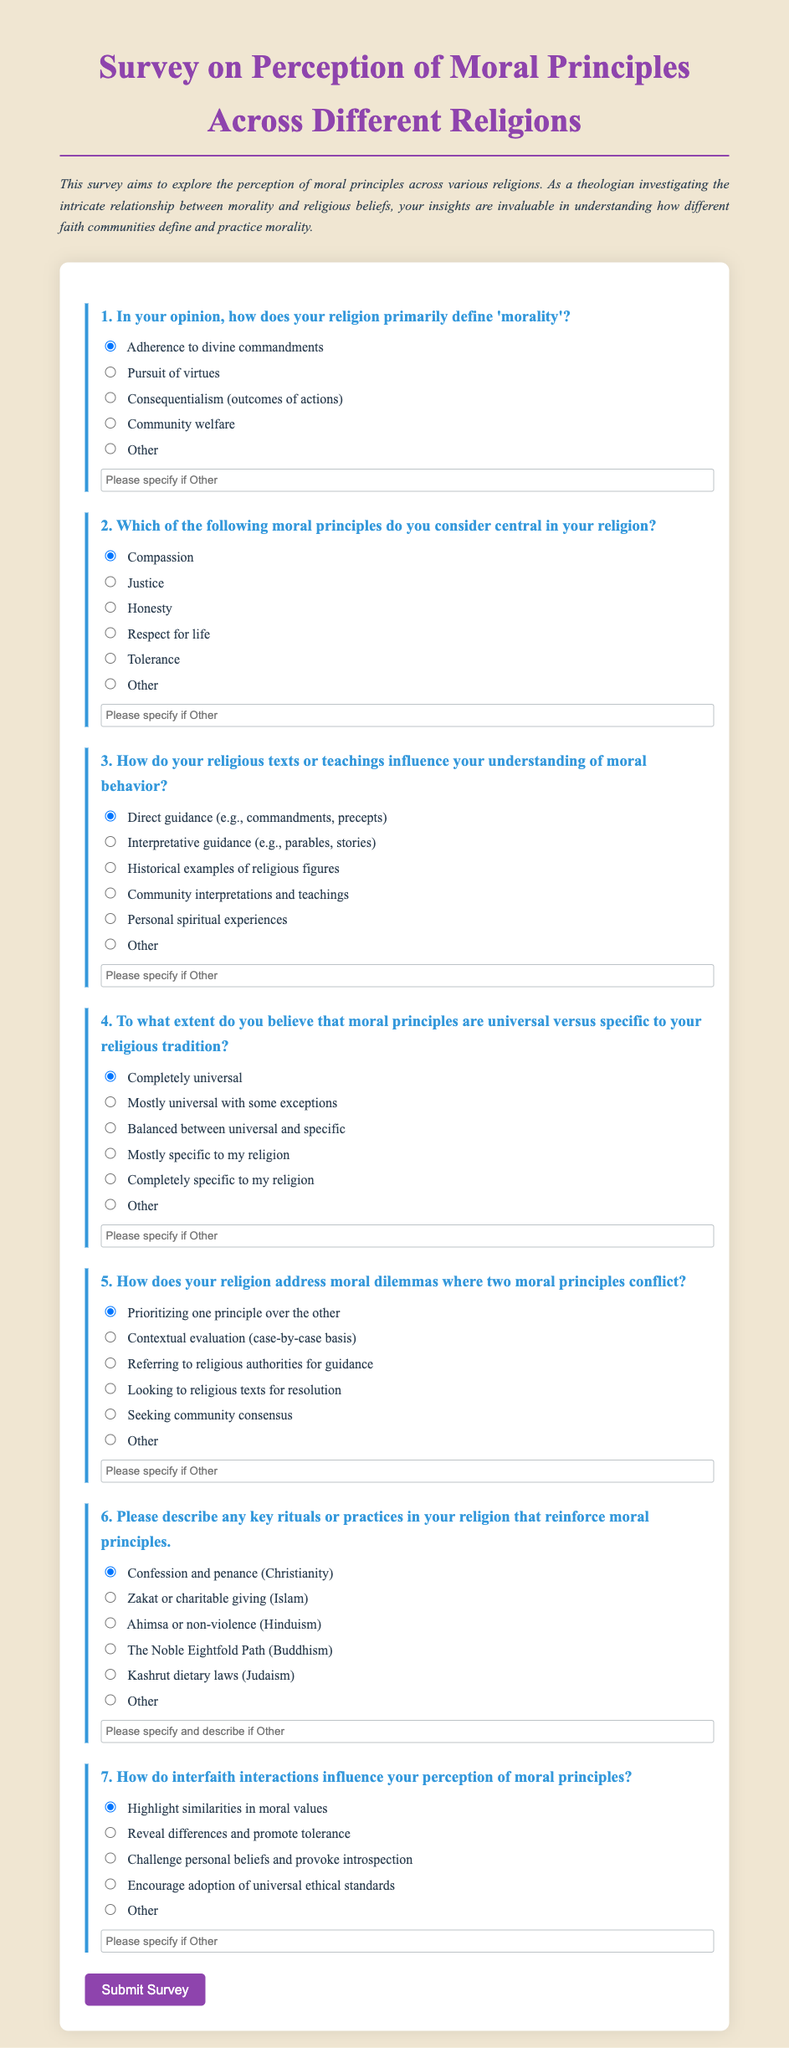What is the title of the survey? The title of the survey is presented prominently at the top of the document.
Answer: Survey on Perception of Moral Principles Across Different Religions How many questions are in the survey? The document lists seven questions within the survey form.
Answer: 7 What is the first moral principle listed as central to religion? The first option presented for central moral principles in the survey is shown in the multiple-choice list.
Answer: Compassion Which religious practice is associated with confession and penance? The practice listed in the survey as associated with confession and penance pertains to a specific religion.
Answer: Christianity What type of guidance includes commandments and precepts? The document describes a type of guidance that includes direct religious instructions relevant to moral behavior.
Answer: Direct guidance How does the survey ask participants to engage with moral dilemmas? The survey offers responses that indicate how participants might approach situations where moral principles conflict, indicating a structured way to respond.
Answer: Prioritizing one principle over the other What color is the background of the survey form? The background color is specified in the document's style section and enhances the visual appeal of the survey.
Answer: #f0e6d2 